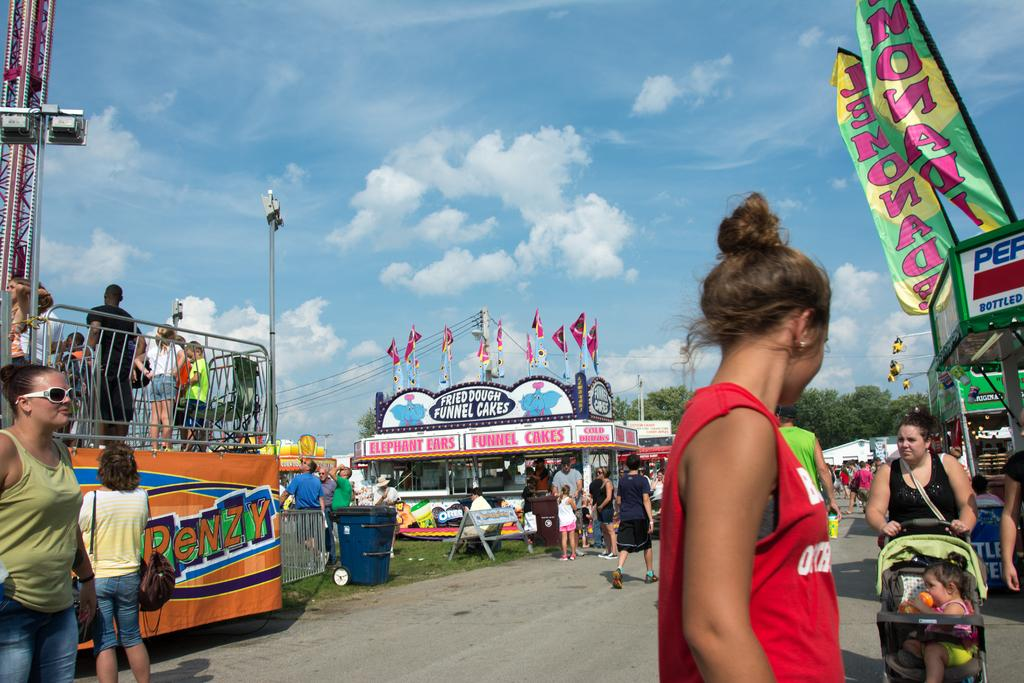What type of structures can be seen in the image? There are stalls in the image. What is happening with the people in the image? There are people walking in the image. What type of vegetation is present in the image? There are trees and grass in the image. What type of infrastructure can be seen in the image? There are electric poles in the image. What can be seen in the sky in the image? There are clouds in the sky in the image. Where is the stage located in the image? There is no stage present in the image. Can you describe the wings of the birds in the image? There are no birds or wings present in the image. 